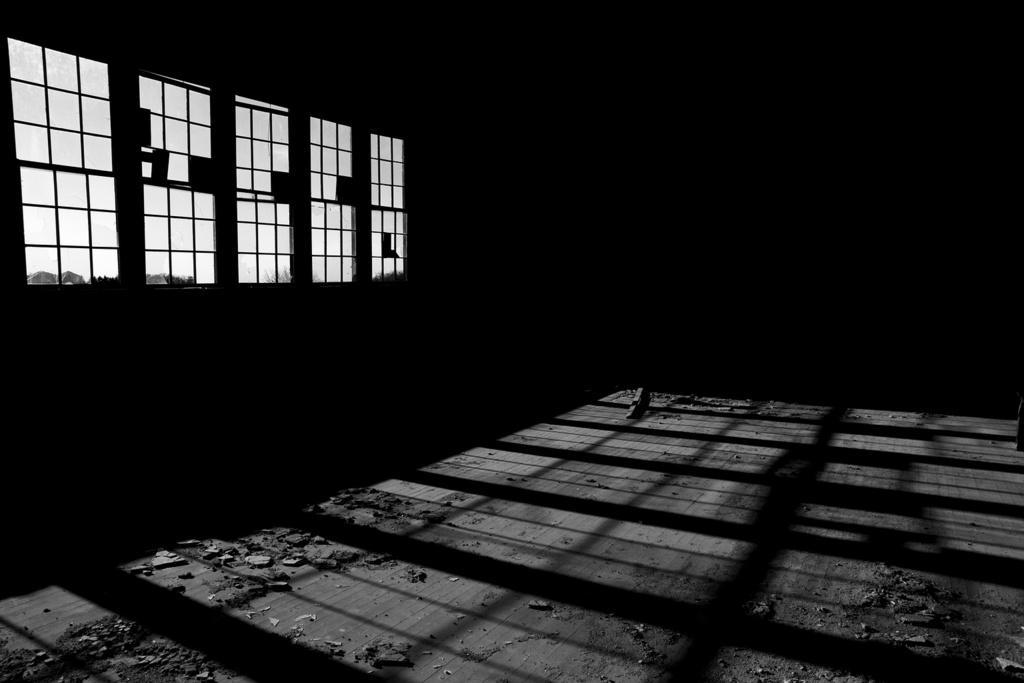Can you describe this image briefly? In this image in the center on the ground there are stones. On the left side there are windows. 